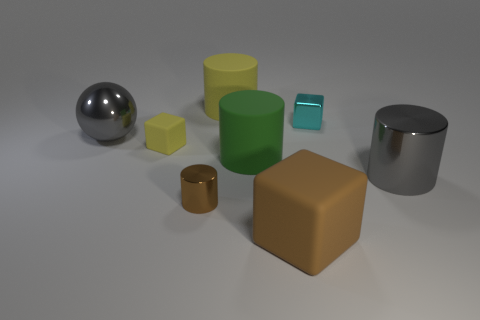There is a cylinder that is the same color as the small rubber object; what size is it?
Offer a very short reply. Large. How many things are big shiny things behind the green matte object or things behind the yellow cube?
Provide a short and direct response. 3. What is the shape of the metallic object that is the same color as the big rubber block?
Provide a succinct answer. Cylinder. What is the shape of the large gray metal object that is to the left of the yellow block?
Keep it short and to the point. Sphere. Do the matte object that is in front of the gray metal cylinder and the tiny cyan metal thing have the same shape?
Your answer should be compact. Yes. How many objects are either objects on the left side of the small yellow matte thing or small balls?
Keep it short and to the point. 1. What color is the other matte thing that is the same shape as the large yellow object?
Your answer should be very brief. Green. Is there any other thing that is the same color as the ball?
Provide a short and direct response. Yes. What is the size of the gray thing that is to the right of the big brown thing?
Your answer should be compact. Large. Does the tiny shiny cylinder have the same color as the matte cube in front of the small yellow object?
Provide a succinct answer. Yes. 